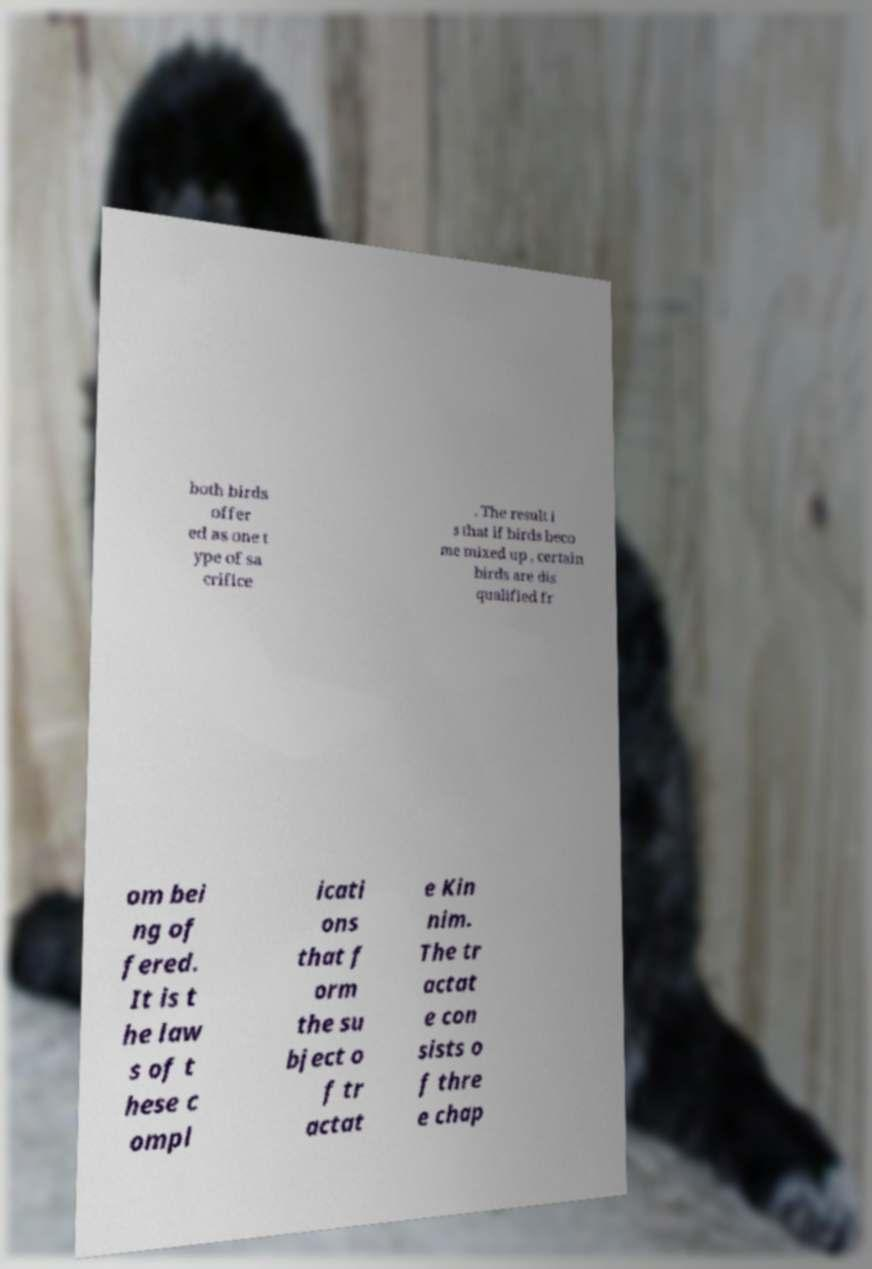What messages or text are displayed in this image? I need them in a readable, typed format. both birds offer ed as one t ype of sa crifice . The result i s that if birds beco me mixed up , certain birds are dis qualified fr om bei ng of fered. It is t he law s of t hese c ompl icati ons that f orm the su bject o f tr actat e Kin nim. The tr actat e con sists o f thre e chap 